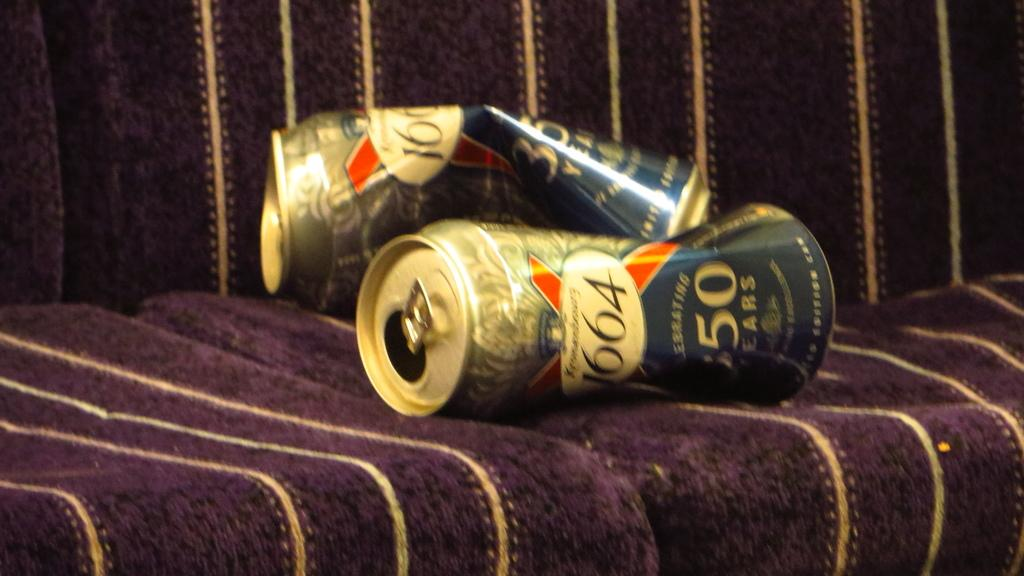<image>
Render a clear and concise summary of the photo. Slightly crushed cans branded 1664 laid on seating. 